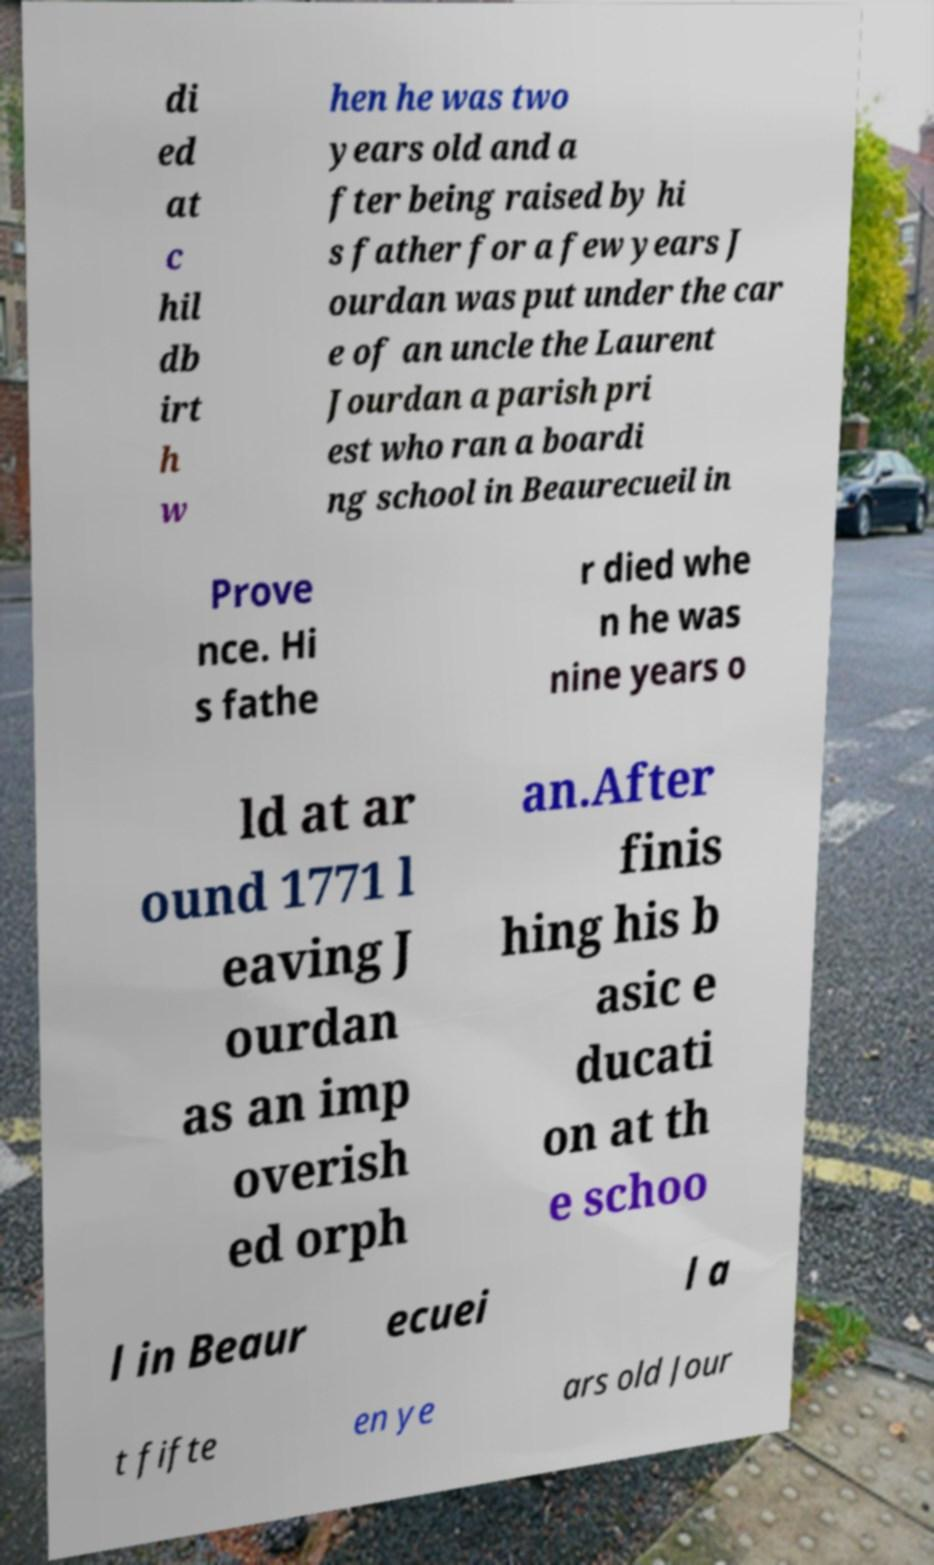I need the written content from this picture converted into text. Can you do that? di ed at c hil db irt h w hen he was two years old and a fter being raised by hi s father for a few years J ourdan was put under the car e of an uncle the Laurent Jourdan a parish pri est who ran a boardi ng school in Beaurecueil in Prove nce. Hi s fathe r died whe n he was nine years o ld at ar ound 1771 l eaving J ourdan as an imp overish ed orph an.After finis hing his b asic e ducati on at th e schoo l in Beaur ecuei l a t fifte en ye ars old Jour 